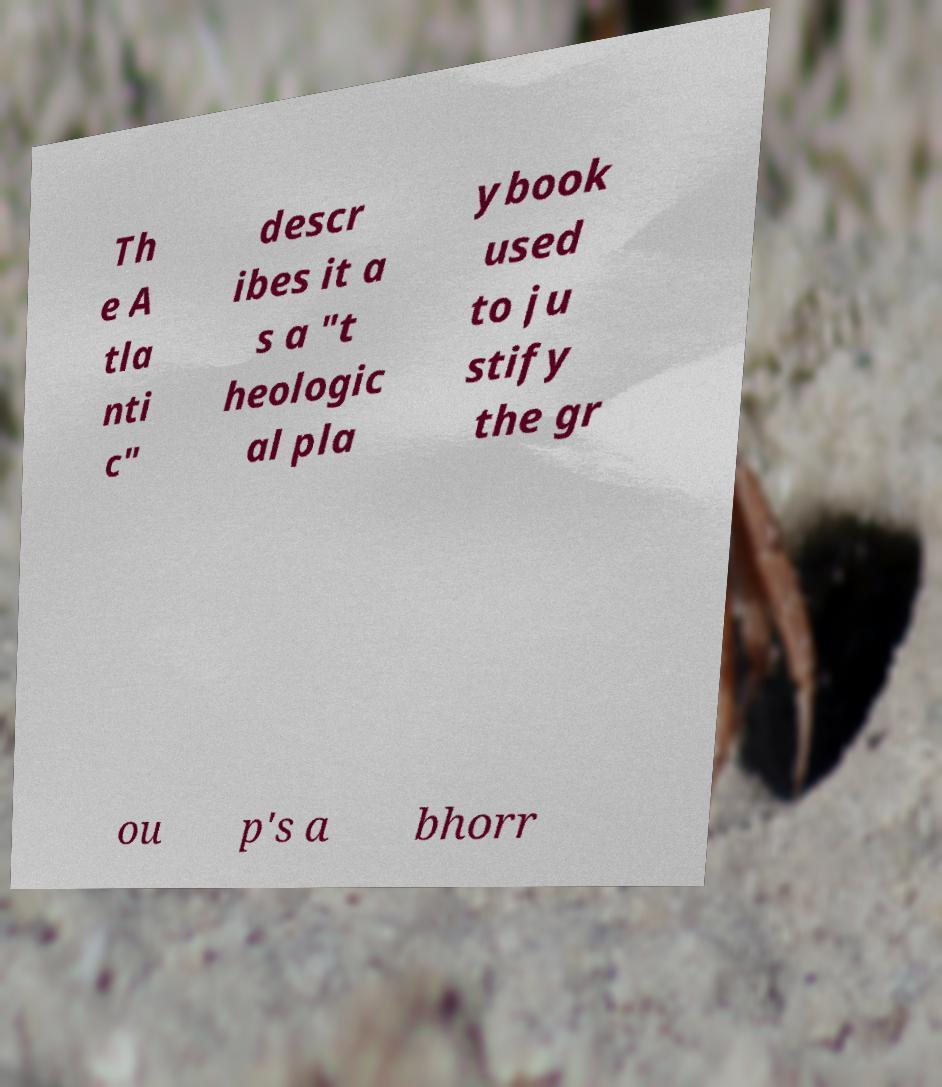Could you extract and type out the text from this image? Th e A tla nti c" descr ibes it a s a "t heologic al pla ybook used to ju stify the gr ou p's a bhorr 